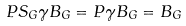<formula> <loc_0><loc_0><loc_500><loc_500>P S _ { G } \gamma B _ { G } = P \gamma B _ { G } = B _ { G }</formula> 